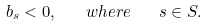<formula> <loc_0><loc_0><loc_500><loc_500>b _ { s } < 0 , \quad w h e r e \quad s \in S .</formula> 